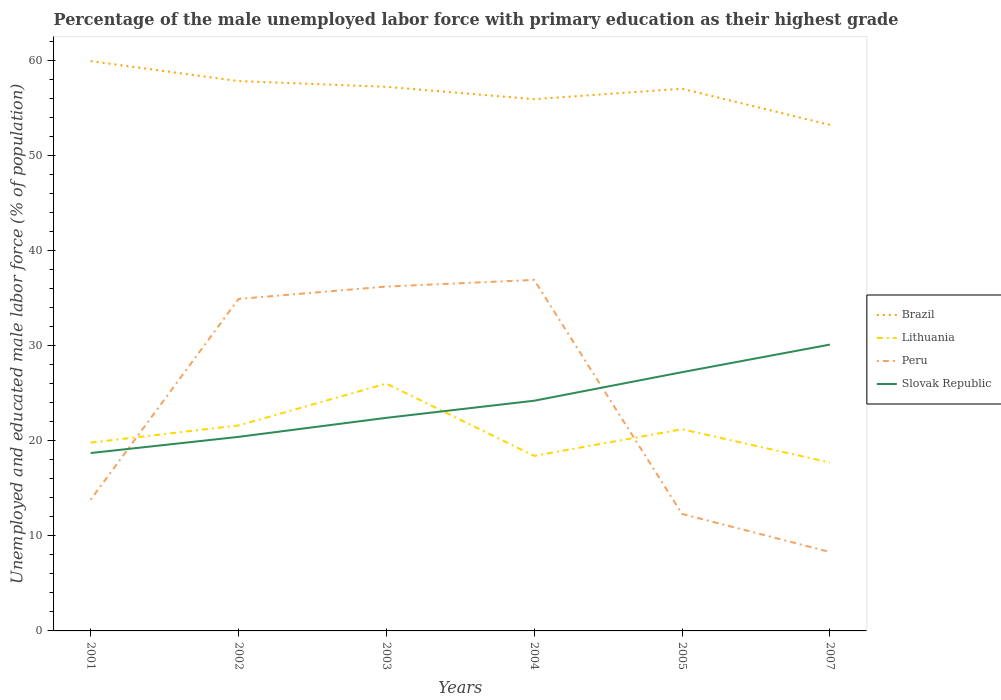Is the number of lines equal to the number of legend labels?
Keep it short and to the point. Yes. Across all years, what is the maximum percentage of the unemployed male labor force with primary education in Slovak Republic?
Provide a succinct answer. 18.7. What is the total percentage of the unemployed male labor force with primary education in Slovak Republic in the graph?
Provide a short and direct response. -3. What is the difference between the highest and the second highest percentage of the unemployed male labor force with primary education in Peru?
Your response must be concise. 28.6. Is the percentage of the unemployed male labor force with primary education in Peru strictly greater than the percentage of the unemployed male labor force with primary education in Lithuania over the years?
Your answer should be compact. No. Are the values on the major ticks of Y-axis written in scientific E-notation?
Keep it short and to the point. No. Does the graph contain grids?
Provide a succinct answer. No. Where does the legend appear in the graph?
Keep it short and to the point. Center right. How many legend labels are there?
Provide a succinct answer. 4. What is the title of the graph?
Your response must be concise. Percentage of the male unemployed labor force with primary education as their highest grade. What is the label or title of the Y-axis?
Your answer should be very brief. Unemployed and educated male labor force (% of population). What is the Unemployed and educated male labor force (% of population) of Brazil in 2001?
Provide a succinct answer. 59.9. What is the Unemployed and educated male labor force (% of population) of Lithuania in 2001?
Your answer should be very brief. 19.8. What is the Unemployed and educated male labor force (% of population) of Peru in 2001?
Your answer should be very brief. 13.8. What is the Unemployed and educated male labor force (% of population) of Slovak Republic in 2001?
Keep it short and to the point. 18.7. What is the Unemployed and educated male labor force (% of population) of Brazil in 2002?
Your answer should be compact. 57.8. What is the Unemployed and educated male labor force (% of population) in Lithuania in 2002?
Provide a short and direct response. 21.6. What is the Unemployed and educated male labor force (% of population) of Peru in 2002?
Give a very brief answer. 34.9. What is the Unemployed and educated male labor force (% of population) in Slovak Republic in 2002?
Give a very brief answer. 20.4. What is the Unemployed and educated male labor force (% of population) of Brazil in 2003?
Provide a succinct answer. 57.2. What is the Unemployed and educated male labor force (% of population) in Lithuania in 2003?
Ensure brevity in your answer.  26. What is the Unemployed and educated male labor force (% of population) in Peru in 2003?
Provide a succinct answer. 36.2. What is the Unemployed and educated male labor force (% of population) in Slovak Republic in 2003?
Offer a terse response. 22.4. What is the Unemployed and educated male labor force (% of population) in Brazil in 2004?
Provide a short and direct response. 55.9. What is the Unemployed and educated male labor force (% of population) in Lithuania in 2004?
Give a very brief answer. 18.4. What is the Unemployed and educated male labor force (% of population) in Peru in 2004?
Your answer should be compact. 36.9. What is the Unemployed and educated male labor force (% of population) of Slovak Republic in 2004?
Offer a terse response. 24.2. What is the Unemployed and educated male labor force (% of population) in Brazil in 2005?
Keep it short and to the point. 57. What is the Unemployed and educated male labor force (% of population) of Lithuania in 2005?
Give a very brief answer. 21.2. What is the Unemployed and educated male labor force (% of population) of Peru in 2005?
Give a very brief answer. 12.3. What is the Unemployed and educated male labor force (% of population) in Slovak Republic in 2005?
Your answer should be very brief. 27.2. What is the Unemployed and educated male labor force (% of population) of Brazil in 2007?
Your answer should be compact. 53.2. What is the Unemployed and educated male labor force (% of population) of Lithuania in 2007?
Make the answer very short. 17.7. What is the Unemployed and educated male labor force (% of population) in Peru in 2007?
Keep it short and to the point. 8.3. What is the Unemployed and educated male labor force (% of population) in Slovak Republic in 2007?
Give a very brief answer. 30.1. Across all years, what is the maximum Unemployed and educated male labor force (% of population) in Brazil?
Provide a succinct answer. 59.9. Across all years, what is the maximum Unemployed and educated male labor force (% of population) in Lithuania?
Offer a terse response. 26. Across all years, what is the maximum Unemployed and educated male labor force (% of population) in Peru?
Your answer should be compact. 36.9. Across all years, what is the maximum Unemployed and educated male labor force (% of population) in Slovak Republic?
Your answer should be very brief. 30.1. Across all years, what is the minimum Unemployed and educated male labor force (% of population) of Brazil?
Provide a succinct answer. 53.2. Across all years, what is the minimum Unemployed and educated male labor force (% of population) of Lithuania?
Offer a terse response. 17.7. Across all years, what is the minimum Unemployed and educated male labor force (% of population) in Peru?
Provide a short and direct response. 8.3. Across all years, what is the minimum Unemployed and educated male labor force (% of population) in Slovak Republic?
Make the answer very short. 18.7. What is the total Unemployed and educated male labor force (% of population) in Brazil in the graph?
Your response must be concise. 341. What is the total Unemployed and educated male labor force (% of population) of Lithuania in the graph?
Your response must be concise. 124.7. What is the total Unemployed and educated male labor force (% of population) in Peru in the graph?
Make the answer very short. 142.4. What is the total Unemployed and educated male labor force (% of population) of Slovak Republic in the graph?
Provide a short and direct response. 143. What is the difference between the Unemployed and educated male labor force (% of population) in Brazil in 2001 and that in 2002?
Ensure brevity in your answer.  2.1. What is the difference between the Unemployed and educated male labor force (% of population) in Lithuania in 2001 and that in 2002?
Keep it short and to the point. -1.8. What is the difference between the Unemployed and educated male labor force (% of population) of Peru in 2001 and that in 2002?
Offer a terse response. -21.1. What is the difference between the Unemployed and educated male labor force (% of population) of Slovak Republic in 2001 and that in 2002?
Give a very brief answer. -1.7. What is the difference between the Unemployed and educated male labor force (% of population) of Brazil in 2001 and that in 2003?
Your response must be concise. 2.7. What is the difference between the Unemployed and educated male labor force (% of population) of Lithuania in 2001 and that in 2003?
Give a very brief answer. -6.2. What is the difference between the Unemployed and educated male labor force (% of population) of Peru in 2001 and that in 2003?
Ensure brevity in your answer.  -22.4. What is the difference between the Unemployed and educated male labor force (% of population) of Peru in 2001 and that in 2004?
Provide a succinct answer. -23.1. What is the difference between the Unemployed and educated male labor force (% of population) of Slovak Republic in 2001 and that in 2004?
Your answer should be compact. -5.5. What is the difference between the Unemployed and educated male labor force (% of population) of Brazil in 2001 and that in 2005?
Your answer should be very brief. 2.9. What is the difference between the Unemployed and educated male labor force (% of population) of Peru in 2001 and that in 2007?
Provide a succinct answer. 5.5. What is the difference between the Unemployed and educated male labor force (% of population) of Slovak Republic in 2001 and that in 2007?
Your response must be concise. -11.4. What is the difference between the Unemployed and educated male labor force (% of population) of Brazil in 2002 and that in 2003?
Offer a very short reply. 0.6. What is the difference between the Unemployed and educated male labor force (% of population) in Lithuania in 2002 and that in 2003?
Keep it short and to the point. -4.4. What is the difference between the Unemployed and educated male labor force (% of population) of Lithuania in 2002 and that in 2004?
Make the answer very short. 3.2. What is the difference between the Unemployed and educated male labor force (% of population) of Peru in 2002 and that in 2004?
Give a very brief answer. -2. What is the difference between the Unemployed and educated male labor force (% of population) of Slovak Republic in 2002 and that in 2004?
Make the answer very short. -3.8. What is the difference between the Unemployed and educated male labor force (% of population) in Brazil in 2002 and that in 2005?
Your answer should be compact. 0.8. What is the difference between the Unemployed and educated male labor force (% of population) of Peru in 2002 and that in 2005?
Your answer should be compact. 22.6. What is the difference between the Unemployed and educated male labor force (% of population) of Slovak Republic in 2002 and that in 2005?
Offer a terse response. -6.8. What is the difference between the Unemployed and educated male labor force (% of population) in Brazil in 2002 and that in 2007?
Keep it short and to the point. 4.6. What is the difference between the Unemployed and educated male labor force (% of population) of Lithuania in 2002 and that in 2007?
Offer a very short reply. 3.9. What is the difference between the Unemployed and educated male labor force (% of population) of Peru in 2002 and that in 2007?
Provide a succinct answer. 26.6. What is the difference between the Unemployed and educated male labor force (% of population) in Slovak Republic in 2002 and that in 2007?
Keep it short and to the point. -9.7. What is the difference between the Unemployed and educated male labor force (% of population) in Peru in 2003 and that in 2004?
Provide a succinct answer. -0.7. What is the difference between the Unemployed and educated male labor force (% of population) in Slovak Republic in 2003 and that in 2004?
Your answer should be very brief. -1.8. What is the difference between the Unemployed and educated male labor force (% of population) of Lithuania in 2003 and that in 2005?
Provide a short and direct response. 4.8. What is the difference between the Unemployed and educated male labor force (% of population) in Peru in 2003 and that in 2005?
Offer a terse response. 23.9. What is the difference between the Unemployed and educated male labor force (% of population) in Peru in 2003 and that in 2007?
Offer a very short reply. 27.9. What is the difference between the Unemployed and educated male labor force (% of population) in Brazil in 2004 and that in 2005?
Provide a short and direct response. -1.1. What is the difference between the Unemployed and educated male labor force (% of population) of Peru in 2004 and that in 2005?
Offer a terse response. 24.6. What is the difference between the Unemployed and educated male labor force (% of population) in Peru in 2004 and that in 2007?
Your answer should be very brief. 28.6. What is the difference between the Unemployed and educated male labor force (% of population) of Brazil in 2005 and that in 2007?
Ensure brevity in your answer.  3.8. What is the difference between the Unemployed and educated male labor force (% of population) of Lithuania in 2005 and that in 2007?
Provide a succinct answer. 3.5. What is the difference between the Unemployed and educated male labor force (% of population) of Slovak Republic in 2005 and that in 2007?
Your response must be concise. -2.9. What is the difference between the Unemployed and educated male labor force (% of population) of Brazil in 2001 and the Unemployed and educated male labor force (% of population) of Lithuania in 2002?
Provide a short and direct response. 38.3. What is the difference between the Unemployed and educated male labor force (% of population) of Brazil in 2001 and the Unemployed and educated male labor force (% of population) of Slovak Republic in 2002?
Give a very brief answer. 39.5. What is the difference between the Unemployed and educated male labor force (% of population) in Lithuania in 2001 and the Unemployed and educated male labor force (% of population) in Peru in 2002?
Offer a very short reply. -15.1. What is the difference between the Unemployed and educated male labor force (% of population) in Peru in 2001 and the Unemployed and educated male labor force (% of population) in Slovak Republic in 2002?
Provide a succinct answer. -6.6. What is the difference between the Unemployed and educated male labor force (% of population) of Brazil in 2001 and the Unemployed and educated male labor force (% of population) of Lithuania in 2003?
Ensure brevity in your answer.  33.9. What is the difference between the Unemployed and educated male labor force (% of population) in Brazil in 2001 and the Unemployed and educated male labor force (% of population) in Peru in 2003?
Offer a terse response. 23.7. What is the difference between the Unemployed and educated male labor force (% of population) in Brazil in 2001 and the Unemployed and educated male labor force (% of population) in Slovak Republic in 2003?
Provide a short and direct response. 37.5. What is the difference between the Unemployed and educated male labor force (% of population) of Lithuania in 2001 and the Unemployed and educated male labor force (% of population) of Peru in 2003?
Ensure brevity in your answer.  -16.4. What is the difference between the Unemployed and educated male labor force (% of population) in Lithuania in 2001 and the Unemployed and educated male labor force (% of population) in Slovak Republic in 2003?
Your answer should be very brief. -2.6. What is the difference between the Unemployed and educated male labor force (% of population) of Brazil in 2001 and the Unemployed and educated male labor force (% of population) of Lithuania in 2004?
Make the answer very short. 41.5. What is the difference between the Unemployed and educated male labor force (% of population) in Brazil in 2001 and the Unemployed and educated male labor force (% of population) in Slovak Republic in 2004?
Ensure brevity in your answer.  35.7. What is the difference between the Unemployed and educated male labor force (% of population) of Lithuania in 2001 and the Unemployed and educated male labor force (% of population) of Peru in 2004?
Provide a succinct answer. -17.1. What is the difference between the Unemployed and educated male labor force (% of population) in Lithuania in 2001 and the Unemployed and educated male labor force (% of population) in Slovak Republic in 2004?
Offer a very short reply. -4.4. What is the difference between the Unemployed and educated male labor force (% of population) of Peru in 2001 and the Unemployed and educated male labor force (% of population) of Slovak Republic in 2004?
Your answer should be very brief. -10.4. What is the difference between the Unemployed and educated male labor force (% of population) of Brazil in 2001 and the Unemployed and educated male labor force (% of population) of Lithuania in 2005?
Provide a succinct answer. 38.7. What is the difference between the Unemployed and educated male labor force (% of population) of Brazil in 2001 and the Unemployed and educated male labor force (% of population) of Peru in 2005?
Offer a very short reply. 47.6. What is the difference between the Unemployed and educated male labor force (% of population) of Brazil in 2001 and the Unemployed and educated male labor force (% of population) of Slovak Republic in 2005?
Ensure brevity in your answer.  32.7. What is the difference between the Unemployed and educated male labor force (% of population) of Lithuania in 2001 and the Unemployed and educated male labor force (% of population) of Peru in 2005?
Keep it short and to the point. 7.5. What is the difference between the Unemployed and educated male labor force (% of population) of Peru in 2001 and the Unemployed and educated male labor force (% of population) of Slovak Republic in 2005?
Offer a very short reply. -13.4. What is the difference between the Unemployed and educated male labor force (% of population) of Brazil in 2001 and the Unemployed and educated male labor force (% of population) of Lithuania in 2007?
Provide a succinct answer. 42.2. What is the difference between the Unemployed and educated male labor force (% of population) in Brazil in 2001 and the Unemployed and educated male labor force (% of population) in Peru in 2007?
Make the answer very short. 51.6. What is the difference between the Unemployed and educated male labor force (% of population) in Brazil in 2001 and the Unemployed and educated male labor force (% of population) in Slovak Republic in 2007?
Make the answer very short. 29.8. What is the difference between the Unemployed and educated male labor force (% of population) of Lithuania in 2001 and the Unemployed and educated male labor force (% of population) of Peru in 2007?
Your answer should be compact. 11.5. What is the difference between the Unemployed and educated male labor force (% of population) in Lithuania in 2001 and the Unemployed and educated male labor force (% of population) in Slovak Republic in 2007?
Keep it short and to the point. -10.3. What is the difference between the Unemployed and educated male labor force (% of population) in Peru in 2001 and the Unemployed and educated male labor force (% of population) in Slovak Republic in 2007?
Provide a short and direct response. -16.3. What is the difference between the Unemployed and educated male labor force (% of population) of Brazil in 2002 and the Unemployed and educated male labor force (% of population) of Lithuania in 2003?
Provide a succinct answer. 31.8. What is the difference between the Unemployed and educated male labor force (% of population) of Brazil in 2002 and the Unemployed and educated male labor force (% of population) of Peru in 2003?
Keep it short and to the point. 21.6. What is the difference between the Unemployed and educated male labor force (% of population) in Brazil in 2002 and the Unemployed and educated male labor force (% of population) in Slovak Republic in 2003?
Make the answer very short. 35.4. What is the difference between the Unemployed and educated male labor force (% of population) in Lithuania in 2002 and the Unemployed and educated male labor force (% of population) in Peru in 2003?
Your answer should be very brief. -14.6. What is the difference between the Unemployed and educated male labor force (% of population) of Lithuania in 2002 and the Unemployed and educated male labor force (% of population) of Slovak Republic in 2003?
Your answer should be very brief. -0.8. What is the difference between the Unemployed and educated male labor force (% of population) in Brazil in 2002 and the Unemployed and educated male labor force (% of population) in Lithuania in 2004?
Give a very brief answer. 39.4. What is the difference between the Unemployed and educated male labor force (% of population) in Brazil in 2002 and the Unemployed and educated male labor force (% of population) in Peru in 2004?
Give a very brief answer. 20.9. What is the difference between the Unemployed and educated male labor force (% of population) in Brazil in 2002 and the Unemployed and educated male labor force (% of population) in Slovak Republic in 2004?
Keep it short and to the point. 33.6. What is the difference between the Unemployed and educated male labor force (% of population) in Lithuania in 2002 and the Unemployed and educated male labor force (% of population) in Peru in 2004?
Offer a terse response. -15.3. What is the difference between the Unemployed and educated male labor force (% of population) of Brazil in 2002 and the Unemployed and educated male labor force (% of population) of Lithuania in 2005?
Offer a terse response. 36.6. What is the difference between the Unemployed and educated male labor force (% of population) of Brazil in 2002 and the Unemployed and educated male labor force (% of population) of Peru in 2005?
Make the answer very short. 45.5. What is the difference between the Unemployed and educated male labor force (% of population) in Brazil in 2002 and the Unemployed and educated male labor force (% of population) in Slovak Republic in 2005?
Provide a succinct answer. 30.6. What is the difference between the Unemployed and educated male labor force (% of population) of Peru in 2002 and the Unemployed and educated male labor force (% of population) of Slovak Republic in 2005?
Your answer should be very brief. 7.7. What is the difference between the Unemployed and educated male labor force (% of population) in Brazil in 2002 and the Unemployed and educated male labor force (% of population) in Lithuania in 2007?
Offer a very short reply. 40.1. What is the difference between the Unemployed and educated male labor force (% of population) of Brazil in 2002 and the Unemployed and educated male labor force (% of population) of Peru in 2007?
Provide a succinct answer. 49.5. What is the difference between the Unemployed and educated male labor force (% of population) of Brazil in 2002 and the Unemployed and educated male labor force (% of population) of Slovak Republic in 2007?
Your response must be concise. 27.7. What is the difference between the Unemployed and educated male labor force (% of population) in Lithuania in 2002 and the Unemployed and educated male labor force (% of population) in Peru in 2007?
Provide a short and direct response. 13.3. What is the difference between the Unemployed and educated male labor force (% of population) of Lithuania in 2002 and the Unemployed and educated male labor force (% of population) of Slovak Republic in 2007?
Your response must be concise. -8.5. What is the difference between the Unemployed and educated male labor force (% of population) of Brazil in 2003 and the Unemployed and educated male labor force (% of population) of Lithuania in 2004?
Offer a very short reply. 38.8. What is the difference between the Unemployed and educated male labor force (% of population) in Brazil in 2003 and the Unemployed and educated male labor force (% of population) in Peru in 2004?
Give a very brief answer. 20.3. What is the difference between the Unemployed and educated male labor force (% of population) in Lithuania in 2003 and the Unemployed and educated male labor force (% of population) in Peru in 2004?
Give a very brief answer. -10.9. What is the difference between the Unemployed and educated male labor force (% of population) of Brazil in 2003 and the Unemployed and educated male labor force (% of population) of Peru in 2005?
Make the answer very short. 44.9. What is the difference between the Unemployed and educated male labor force (% of population) of Lithuania in 2003 and the Unemployed and educated male labor force (% of population) of Slovak Republic in 2005?
Ensure brevity in your answer.  -1.2. What is the difference between the Unemployed and educated male labor force (% of population) of Brazil in 2003 and the Unemployed and educated male labor force (% of population) of Lithuania in 2007?
Provide a short and direct response. 39.5. What is the difference between the Unemployed and educated male labor force (% of population) in Brazil in 2003 and the Unemployed and educated male labor force (% of population) in Peru in 2007?
Your answer should be very brief. 48.9. What is the difference between the Unemployed and educated male labor force (% of population) of Brazil in 2003 and the Unemployed and educated male labor force (% of population) of Slovak Republic in 2007?
Keep it short and to the point. 27.1. What is the difference between the Unemployed and educated male labor force (% of population) in Lithuania in 2003 and the Unemployed and educated male labor force (% of population) in Peru in 2007?
Your response must be concise. 17.7. What is the difference between the Unemployed and educated male labor force (% of population) of Lithuania in 2003 and the Unemployed and educated male labor force (% of population) of Slovak Republic in 2007?
Offer a terse response. -4.1. What is the difference between the Unemployed and educated male labor force (% of population) in Brazil in 2004 and the Unemployed and educated male labor force (% of population) in Lithuania in 2005?
Your response must be concise. 34.7. What is the difference between the Unemployed and educated male labor force (% of population) of Brazil in 2004 and the Unemployed and educated male labor force (% of population) of Peru in 2005?
Keep it short and to the point. 43.6. What is the difference between the Unemployed and educated male labor force (% of population) in Brazil in 2004 and the Unemployed and educated male labor force (% of population) in Slovak Republic in 2005?
Your answer should be very brief. 28.7. What is the difference between the Unemployed and educated male labor force (% of population) in Lithuania in 2004 and the Unemployed and educated male labor force (% of population) in Peru in 2005?
Provide a short and direct response. 6.1. What is the difference between the Unemployed and educated male labor force (% of population) in Lithuania in 2004 and the Unemployed and educated male labor force (% of population) in Slovak Republic in 2005?
Offer a terse response. -8.8. What is the difference between the Unemployed and educated male labor force (% of population) of Peru in 2004 and the Unemployed and educated male labor force (% of population) of Slovak Republic in 2005?
Offer a terse response. 9.7. What is the difference between the Unemployed and educated male labor force (% of population) in Brazil in 2004 and the Unemployed and educated male labor force (% of population) in Lithuania in 2007?
Make the answer very short. 38.2. What is the difference between the Unemployed and educated male labor force (% of population) of Brazil in 2004 and the Unemployed and educated male labor force (% of population) of Peru in 2007?
Provide a short and direct response. 47.6. What is the difference between the Unemployed and educated male labor force (% of population) in Brazil in 2004 and the Unemployed and educated male labor force (% of population) in Slovak Republic in 2007?
Your answer should be compact. 25.8. What is the difference between the Unemployed and educated male labor force (% of population) in Lithuania in 2004 and the Unemployed and educated male labor force (% of population) in Peru in 2007?
Ensure brevity in your answer.  10.1. What is the difference between the Unemployed and educated male labor force (% of population) of Brazil in 2005 and the Unemployed and educated male labor force (% of population) of Lithuania in 2007?
Ensure brevity in your answer.  39.3. What is the difference between the Unemployed and educated male labor force (% of population) of Brazil in 2005 and the Unemployed and educated male labor force (% of population) of Peru in 2007?
Give a very brief answer. 48.7. What is the difference between the Unemployed and educated male labor force (% of population) in Brazil in 2005 and the Unemployed and educated male labor force (% of population) in Slovak Republic in 2007?
Give a very brief answer. 26.9. What is the difference between the Unemployed and educated male labor force (% of population) in Peru in 2005 and the Unemployed and educated male labor force (% of population) in Slovak Republic in 2007?
Provide a short and direct response. -17.8. What is the average Unemployed and educated male labor force (% of population) of Brazil per year?
Provide a short and direct response. 56.83. What is the average Unemployed and educated male labor force (% of population) of Lithuania per year?
Provide a succinct answer. 20.78. What is the average Unemployed and educated male labor force (% of population) of Peru per year?
Provide a succinct answer. 23.73. What is the average Unemployed and educated male labor force (% of population) of Slovak Republic per year?
Your response must be concise. 23.83. In the year 2001, what is the difference between the Unemployed and educated male labor force (% of population) in Brazil and Unemployed and educated male labor force (% of population) in Lithuania?
Make the answer very short. 40.1. In the year 2001, what is the difference between the Unemployed and educated male labor force (% of population) in Brazil and Unemployed and educated male labor force (% of population) in Peru?
Your response must be concise. 46.1. In the year 2001, what is the difference between the Unemployed and educated male labor force (% of population) in Brazil and Unemployed and educated male labor force (% of population) in Slovak Republic?
Your response must be concise. 41.2. In the year 2001, what is the difference between the Unemployed and educated male labor force (% of population) in Peru and Unemployed and educated male labor force (% of population) in Slovak Republic?
Keep it short and to the point. -4.9. In the year 2002, what is the difference between the Unemployed and educated male labor force (% of population) in Brazil and Unemployed and educated male labor force (% of population) in Lithuania?
Your answer should be compact. 36.2. In the year 2002, what is the difference between the Unemployed and educated male labor force (% of population) in Brazil and Unemployed and educated male labor force (% of population) in Peru?
Keep it short and to the point. 22.9. In the year 2002, what is the difference between the Unemployed and educated male labor force (% of population) of Brazil and Unemployed and educated male labor force (% of population) of Slovak Republic?
Ensure brevity in your answer.  37.4. In the year 2003, what is the difference between the Unemployed and educated male labor force (% of population) of Brazil and Unemployed and educated male labor force (% of population) of Lithuania?
Give a very brief answer. 31.2. In the year 2003, what is the difference between the Unemployed and educated male labor force (% of population) in Brazil and Unemployed and educated male labor force (% of population) in Peru?
Give a very brief answer. 21. In the year 2003, what is the difference between the Unemployed and educated male labor force (% of population) of Brazil and Unemployed and educated male labor force (% of population) of Slovak Republic?
Offer a very short reply. 34.8. In the year 2003, what is the difference between the Unemployed and educated male labor force (% of population) of Lithuania and Unemployed and educated male labor force (% of population) of Slovak Republic?
Your answer should be very brief. 3.6. In the year 2003, what is the difference between the Unemployed and educated male labor force (% of population) of Peru and Unemployed and educated male labor force (% of population) of Slovak Republic?
Offer a terse response. 13.8. In the year 2004, what is the difference between the Unemployed and educated male labor force (% of population) of Brazil and Unemployed and educated male labor force (% of population) of Lithuania?
Make the answer very short. 37.5. In the year 2004, what is the difference between the Unemployed and educated male labor force (% of population) in Brazil and Unemployed and educated male labor force (% of population) in Peru?
Keep it short and to the point. 19. In the year 2004, what is the difference between the Unemployed and educated male labor force (% of population) of Brazil and Unemployed and educated male labor force (% of population) of Slovak Republic?
Provide a succinct answer. 31.7. In the year 2004, what is the difference between the Unemployed and educated male labor force (% of population) in Lithuania and Unemployed and educated male labor force (% of population) in Peru?
Offer a terse response. -18.5. In the year 2005, what is the difference between the Unemployed and educated male labor force (% of population) in Brazil and Unemployed and educated male labor force (% of population) in Lithuania?
Make the answer very short. 35.8. In the year 2005, what is the difference between the Unemployed and educated male labor force (% of population) in Brazil and Unemployed and educated male labor force (% of population) in Peru?
Give a very brief answer. 44.7. In the year 2005, what is the difference between the Unemployed and educated male labor force (% of population) of Brazil and Unemployed and educated male labor force (% of population) of Slovak Republic?
Your answer should be compact. 29.8. In the year 2005, what is the difference between the Unemployed and educated male labor force (% of population) of Lithuania and Unemployed and educated male labor force (% of population) of Peru?
Your response must be concise. 8.9. In the year 2005, what is the difference between the Unemployed and educated male labor force (% of population) of Peru and Unemployed and educated male labor force (% of population) of Slovak Republic?
Keep it short and to the point. -14.9. In the year 2007, what is the difference between the Unemployed and educated male labor force (% of population) in Brazil and Unemployed and educated male labor force (% of population) in Lithuania?
Provide a short and direct response. 35.5. In the year 2007, what is the difference between the Unemployed and educated male labor force (% of population) in Brazil and Unemployed and educated male labor force (% of population) in Peru?
Offer a very short reply. 44.9. In the year 2007, what is the difference between the Unemployed and educated male labor force (% of population) in Brazil and Unemployed and educated male labor force (% of population) in Slovak Republic?
Make the answer very short. 23.1. In the year 2007, what is the difference between the Unemployed and educated male labor force (% of population) of Peru and Unemployed and educated male labor force (% of population) of Slovak Republic?
Your answer should be compact. -21.8. What is the ratio of the Unemployed and educated male labor force (% of population) of Brazil in 2001 to that in 2002?
Offer a very short reply. 1.04. What is the ratio of the Unemployed and educated male labor force (% of population) in Lithuania in 2001 to that in 2002?
Ensure brevity in your answer.  0.92. What is the ratio of the Unemployed and educated male labor force (% of population) in Peru in 2001 to that in 2002?
Make the answer very short. 0.4. What is the ratio of the Unemployed and educated male labor force (% of population) of Brazil in 2001 to that in 2003?
Make the answer very short. 1.05. What is the ratio of the Unemployed and educated male labor force (% of population) of Lithuania in 2001 to that in 2003?
Offer a very short reply. 0.76. What is the ratio of the Unemployed and educated male labor force (% of population) of Peru in 2001 to that in 2003?
Your answer should be very brief. 0.38. What is the ratio of the Unemployed and educated male labor force (% of population) in Slovak Republic in 2001 to that in 2003?
Your response must be concise. 0.83. What is the ratio of the Unemployed and educated male labor force (% of population) of Brazil in 2001 to that in 2004?
Give a very brief answer. 1.07. What is the ratio of the Unemployed and educated male labor force (% of population) of Lithuania in 2001 to that in 2004?
Your answer should be very brief. 1.08. What is the ratio of the Unemployed and educated male labor force (% of population) in Peru in 2001 to that in 2004?
Your answer should be very brief. 0.37. What is the ratio of the Unemployed and educated male labor force (% of population) in Slovak Republic in 2001 to that in 2004?
Your response must be concise. 0.77. What is the ratio of the Unemployed and educated male labor force (% of population) in Brazil in 2001 to that in 2005?
Provide a short and direct response. 1.05. What is the ratio of the Unemployed and educated male labor force (% of population) of Lithuania in 2001 to that in 2005?
Your response must be concise. 0.93. What is the ratio of the Unemployed and educated male labor force (% of population) in Peru in 2001 to that in 2005?
Your response must be concise. 1.12. What is the ratio of the Unemployed and educated male labor force (% of population) in Slovak Republic in 2001 to that in 2005?
Make the answer very short. 0.69. What is the ratio of the Unemployed and educated male labor force (% of population) of Brazil in 2001 to that in 2007?
Keep it short and to the point. 1.13. What is the ratio of the Unemployed and educated male labor force (% of population) of Lithuania in 2001 to that in 2007?
Give a very brief answer. 1.12. What is the ratio of the Unemployed and educated male labor force (% of population) of Peru in 2001 to that in 2007?
Make the answer very short. 1.66. What is the ratio of the Unemployed and educated male labor force (% of population) in Slovak Republic in 2001 to that in 2007?
Keep it short and to the point. 0.62. What is the ratio of the Unemployed and educated male labor force (% of population) in Brazil in 2002 to that in 2003?
Make the answer very short. 1.01. What is the ratio of the Unemployed and educated male labor force (% of population) of Lithuania in 2002 to that in 2003?
Your answer should be very brief. 0.83. What is the ratio of the Unemployed and educated male labor force (% of population) in Peru in 2002 to that in 2003?
Your response must be concise. 0.96. What is the ratio of the Unemployed and educated male labor force (% of population) in Slovak Republic in 2002 to that in 2003?
Make the answer very short. 0.91. What is the ratio of the Unemployed and educated male labor force (% of population) of Brazil in 2002 to that in 2004?
Offer a very short reply. 1.03. What is the ratio of the Unemployed and educated male labor force (% of population) of Lithuania in 2002 to that in 2004?
Your answer should be very brief. 1.17. What is the ratio of the Unemployed and educated male labor force (% of population) in Peru in 2002 to that in 2004?
Keep it short and to the point. 0.95. What is the ratio of the Unemployed and educated male labor force (% of population) in Slovak Republic in 2002 to that in 2004?
Your response must be concise. 0.84. What is the ratio of the Unemployed and educated male labor force (% of population) of Lithuania in 2002 to that in 2005?
Give a very brief answer. 1.02. What is the ratio of the Unemployed and educated male labor force (% of population) in Peru in 2002 to that in 2005?
Your answer should be very brief. 2.84. What is the ratio of the Unemployed and educated male labor force (% of population) in Slovak Republic in 2002 to that in 2005?
Your answer should be compact. 0.75. What is the ratio of the Unemployed and educated male labor force (% of population) of Brazil in 2002 to that in 2007?
Your answer should be very brief. 1.09. What is the ratio of the Unemployed and educated male labor force (% of population) in Lithuania in 2002 to that in 2007?
Provide a succinct answer. 1.22. What is the ratio of the Unemployed and educated male labor force (% of population) of Peru in 2002 to that in 2007?
Give a very brief answer. 4.2. What is the ratio of the Unemployed and educated male labor force (% of population) of Slovak Republic in 2002 to that in 2007?
Offer a terse response. 0.68. What is the ratio of the Unemployed and educated male labor force (% of population) in Brazil in 2003 to that in 2004?
Give a very brief answer. 1.02. What is the ratio of the Unemployed and educated male labor force (% of population) in Lithuania in 2003 to that in 2004?
Your answer should be compact. 1.41. What is the ratio of the Unemployed and educated male labor force (% of population) in Peru in 2003 to that in 2004?
Your answer should be very brief. 0.98. What is the ratio of the Unemployed and educated male labor force (% of population) of Slovak Republic in 2003 to that in 2004?
Offer a terse response. 0.93. What is the ratio of the Unemployed and educated male labor force (% of population) in Lithuania in 2003 to that in 2005?
Offer a very short reply. 1.23. What is the ratio of the Unemployed and educated male labor force (% of population) of Peru in 2003 to that in 2005?
Provide a short and direct response. 2.94. What is the ratio of the Unemployed and educated male labor force (% of population) of Slovak Republic in 2003 to that in 2005?
Give a very brief answer. 0.82. What is the ratio of the Unemployed and educated male labor force (% of population) in Brazil in 2003 to that in 2007?
Give a very brief answer. 1.08. What is the ratio of the Unemployed and educated male labor force (% of population) of Lithuania in 2003 to that in 2007?
Your answer should be very brief. 1.47. What is the ratio of the Unemployed and educated male labor force (% of population) of Peru in 2003 to that in 2007?
Ensure brevity in your answer.  4.36. What is the ratio of the Unemployed and educated male labor force (% of population) of Slovak Republic in 2003 to that in 2007?
Make the answer very short. 0.74. What is the ratio of the Unemployed and educated male labor force (% of population) of Brazil in 2004 to that in 2005?
Make the answer very short. 0.98. What is the ratio of the Unemployed and educated male labor force (% of population) in Lithuania in 2004 to that in 2005?
Keep it short and to the point. 0.87. What is the ratio of the Unemployed and educated male labor force (% of population) of Slovak Republic in 2004 to that in 2005?
Your answer should be very brief. 0.89. What is the ratio of the Unemployed and educated male labor force (% of population) in Brazil in 2004 to that in 2007?
Keep it short and to the point. 1.05. What is the ratio of the Unemployed and educated male labor force (% of population) of Lithuania in 2004 to that in 2007?
Provide a short and direct response. 1.04. What is the ratio of the Unemployed and educated male labor force (% of population) in Peru in 2004 to that in 2007?
Provide a succinct answer. 4.45. What is the ratio of the Unemployed and educated male labor force (% of population) in Slovak Republic in 2004 to that in 2007?
Your answer should be very brief. 0.8. What is the ratio of the Unemployed and educated male labor force (% of population) in Brazil in 2005 to that in 2007?
Make the answer very short. 1.07. What is the ratio of the Unemployed and educated male labor force (% of population) in Lithuania in 2005 to that in 2007?
Provide a short and direct response. 1.2. What is the ratio of the Unemployed and educated male labor force (% of population) in Peru in 2005 to that in 2007?
Provide a succinct answer. 1.48. What is the ratio of the Unemployed and educated male labor force (% of population) of Slovak Republic in 2005 to that in 2007?
Ensure brevity in your answer.  0.9. What is the difference between the highest and the lowest Unemployed and educated male labor force (% of population) in Lithuania?
Your answer should be compact. 8.3. What is the difference between the highest and the lowest Unemployed and educated male labor force (% of population) of Peru?
Provide a short and direct response. 28.6. What is the difference between the highest and the lowest Unemployed and educated male labor force (% of population) of Slovak Republic?
Your answer should be very brief. 11.4. 